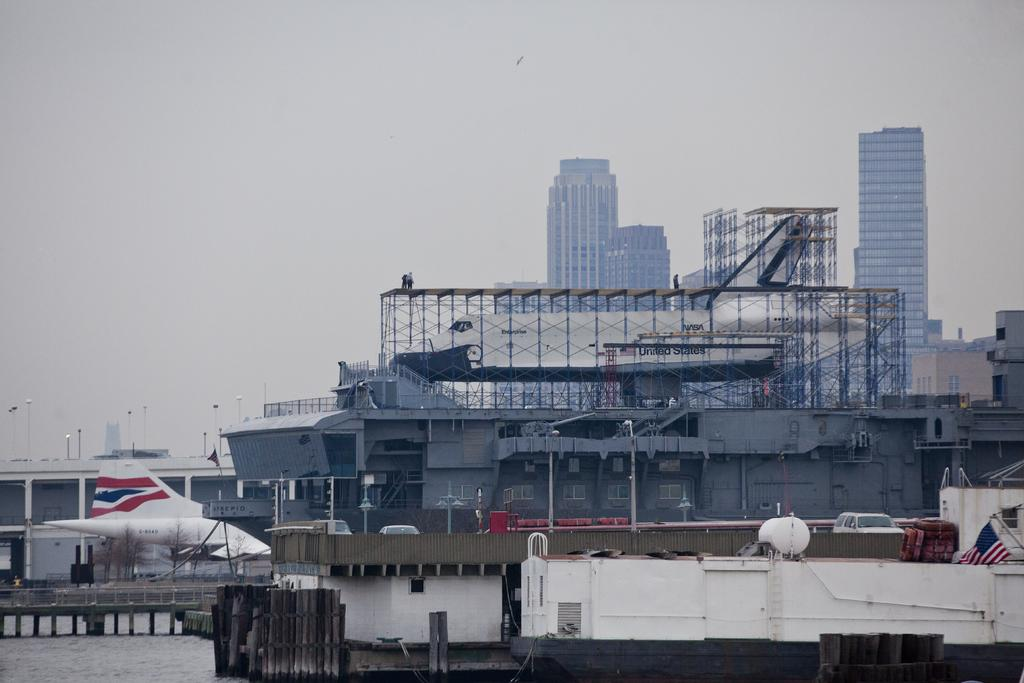What is the main subject in the water in the image? There is a ship in the water in the image. What other mode of transportation can be seen in the image? There is an airplane in the image. What can be seen illuminated in the image? There are lights visible in the image. What type of structures are visible in the background of the image? There are buildings in the background of the image. What is visible in the sky in the background of the image? The sky is visible in the background of the image. How many feet are required to paint the art on the ship in the image? There is no art or painting on the ship in the image, so it is not possible to determine the number of feet required to paint it. 